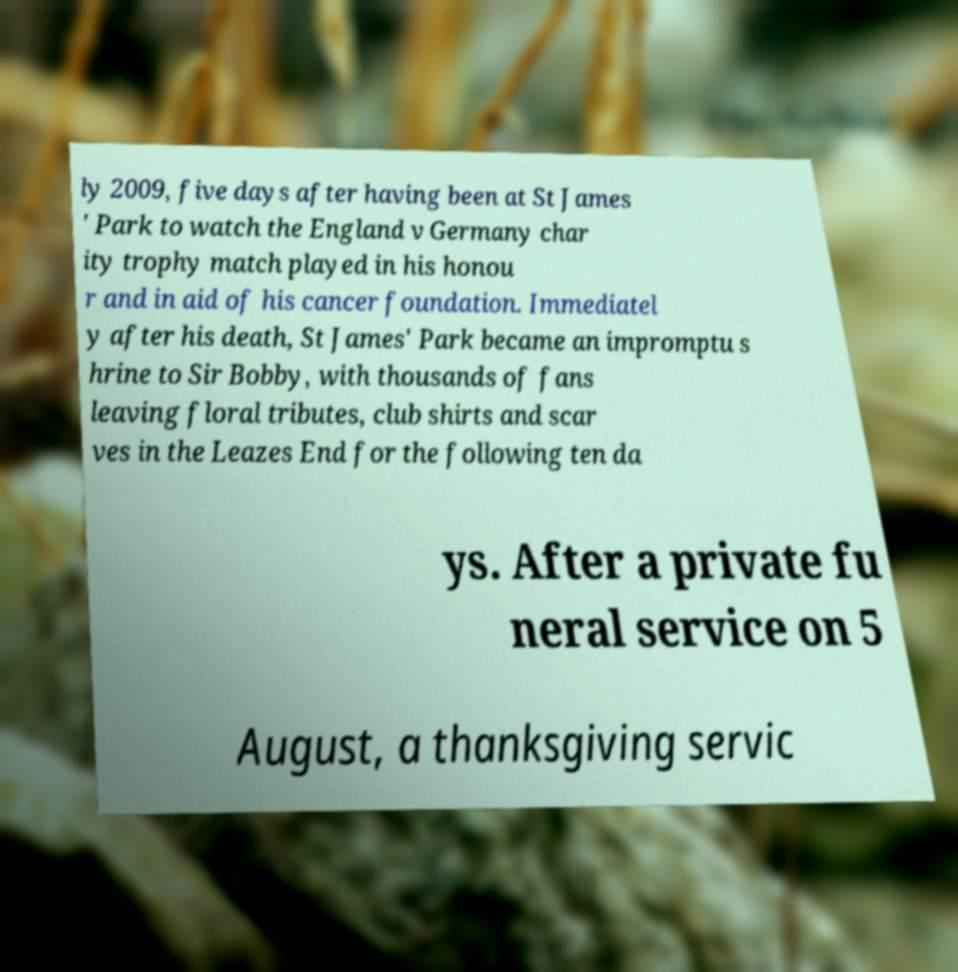Can you read and provide the text displayed in the image?This photo seems to have some interesting text. Can you extract and type it out for me? ly 2009, five days after having been at St James ' Park to watch the England v Germany char ity trophy match played in his honou r and in aid of his cancer foundation. Immediatel y after his death, St James' Park became an impromptu s hrine to Sir Bobby, with thousands of fans leaving floral tributes, club shirts and scar ves in the Leazes End for the following ten da ys. After a private fu neral service on 5 August, a thanksgiving servic 